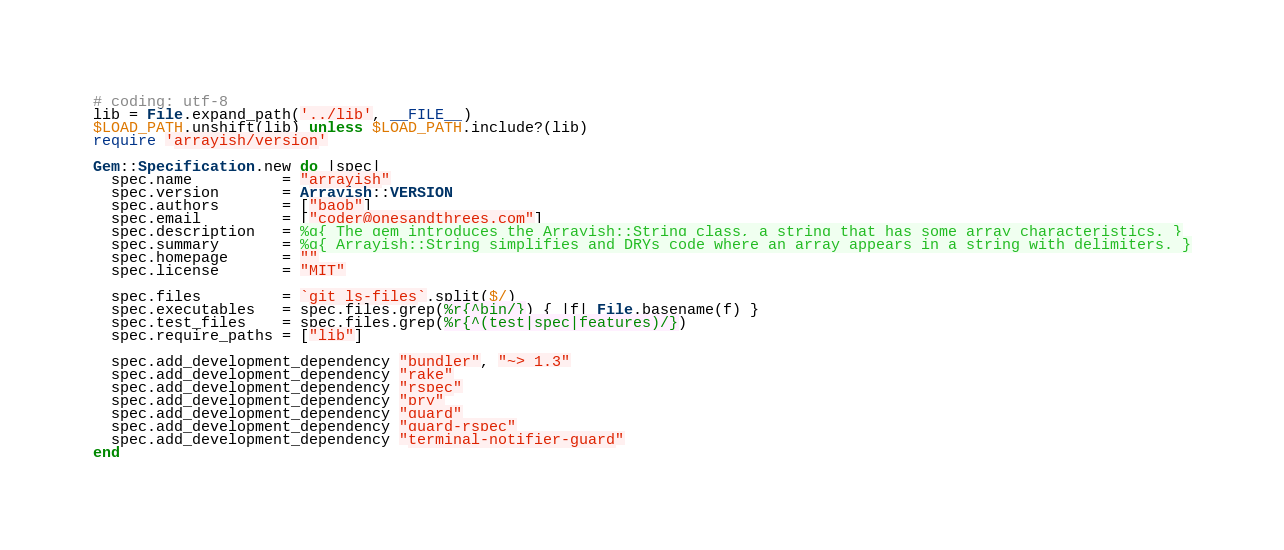Convert code to text. <code><loc_0><loc_0><loc_500><loc_500><_Ruby_># coding: utf-8
lib = File.expand_path('../lib', __FILE__)
$LOAD_PATH.unshift(lib) unless $LOAD_PATH.include?(lib)
require 'arrayish/version'

Gem::Specification.new do |spec|
  spec.name          = "arrayish"
  spec.version       = Arrayish::VERSION
  spec.authors       = ["baob"]
  spec.email         = ["coder@onesandthrees.com"]
  spec.description   = %q{ The gem introduces the Arrayish::String class, a string that has some array characteristics. }
  spec.summary       = %q{ Arrayish::String simplifies and DRYs code where an array appears in a string with delimiters. }
  spec.homepage      = ""
  spec.license       = "MIT"

  spec.files         = `git ls-files`.split($/)
  spec.executables   = spec.files.grep(%r{^bin/}) { |f| File.basename(f) }
  spec.test_files    = spec.files.grep(%r{^(test|spec|features)/})
  spec.require_paths = ["lib"]

  spec.add_development_dependency "bundler", "~> 1.3"
  spec.add_development_dependency "rake"
  spec.add_development_dependency "rspec"
  spec.add_development_dependency "pry"
  spec.add_development_dependency "guard"
  spec.add_development_dependency "guard-rspec"
  spec.add_development_dependency "terminal-notifier-guard"
end
</code> 